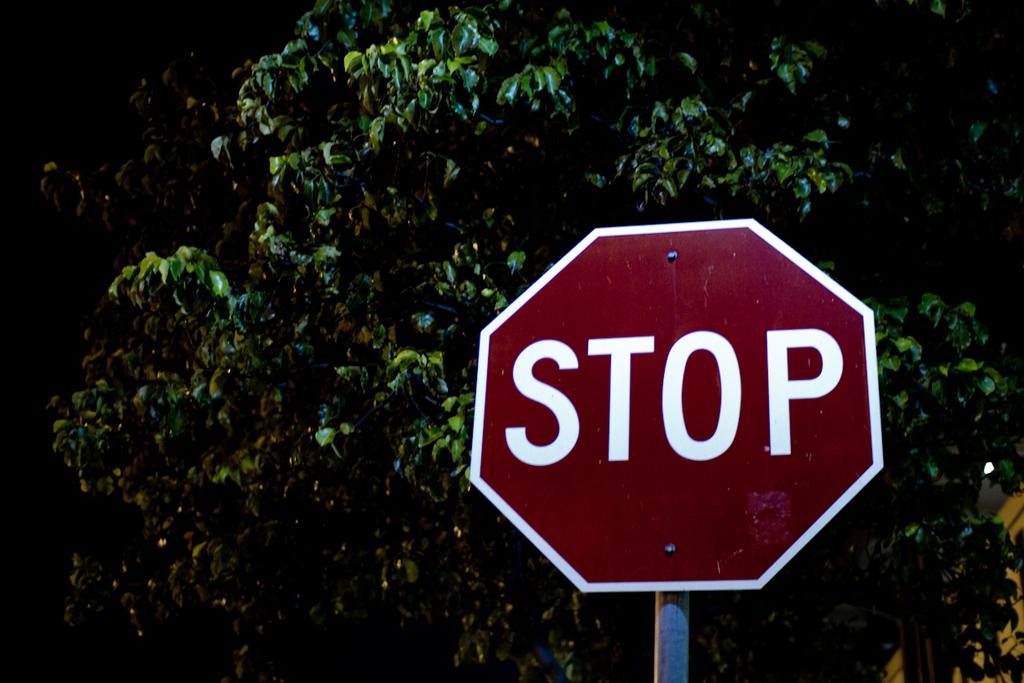What does the sign urge us to do?
Offer a very short reply. Stop. 